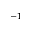<formula> <loc_0><loc_0><loc_500><loc_500>^ { - 1 }</formula> 